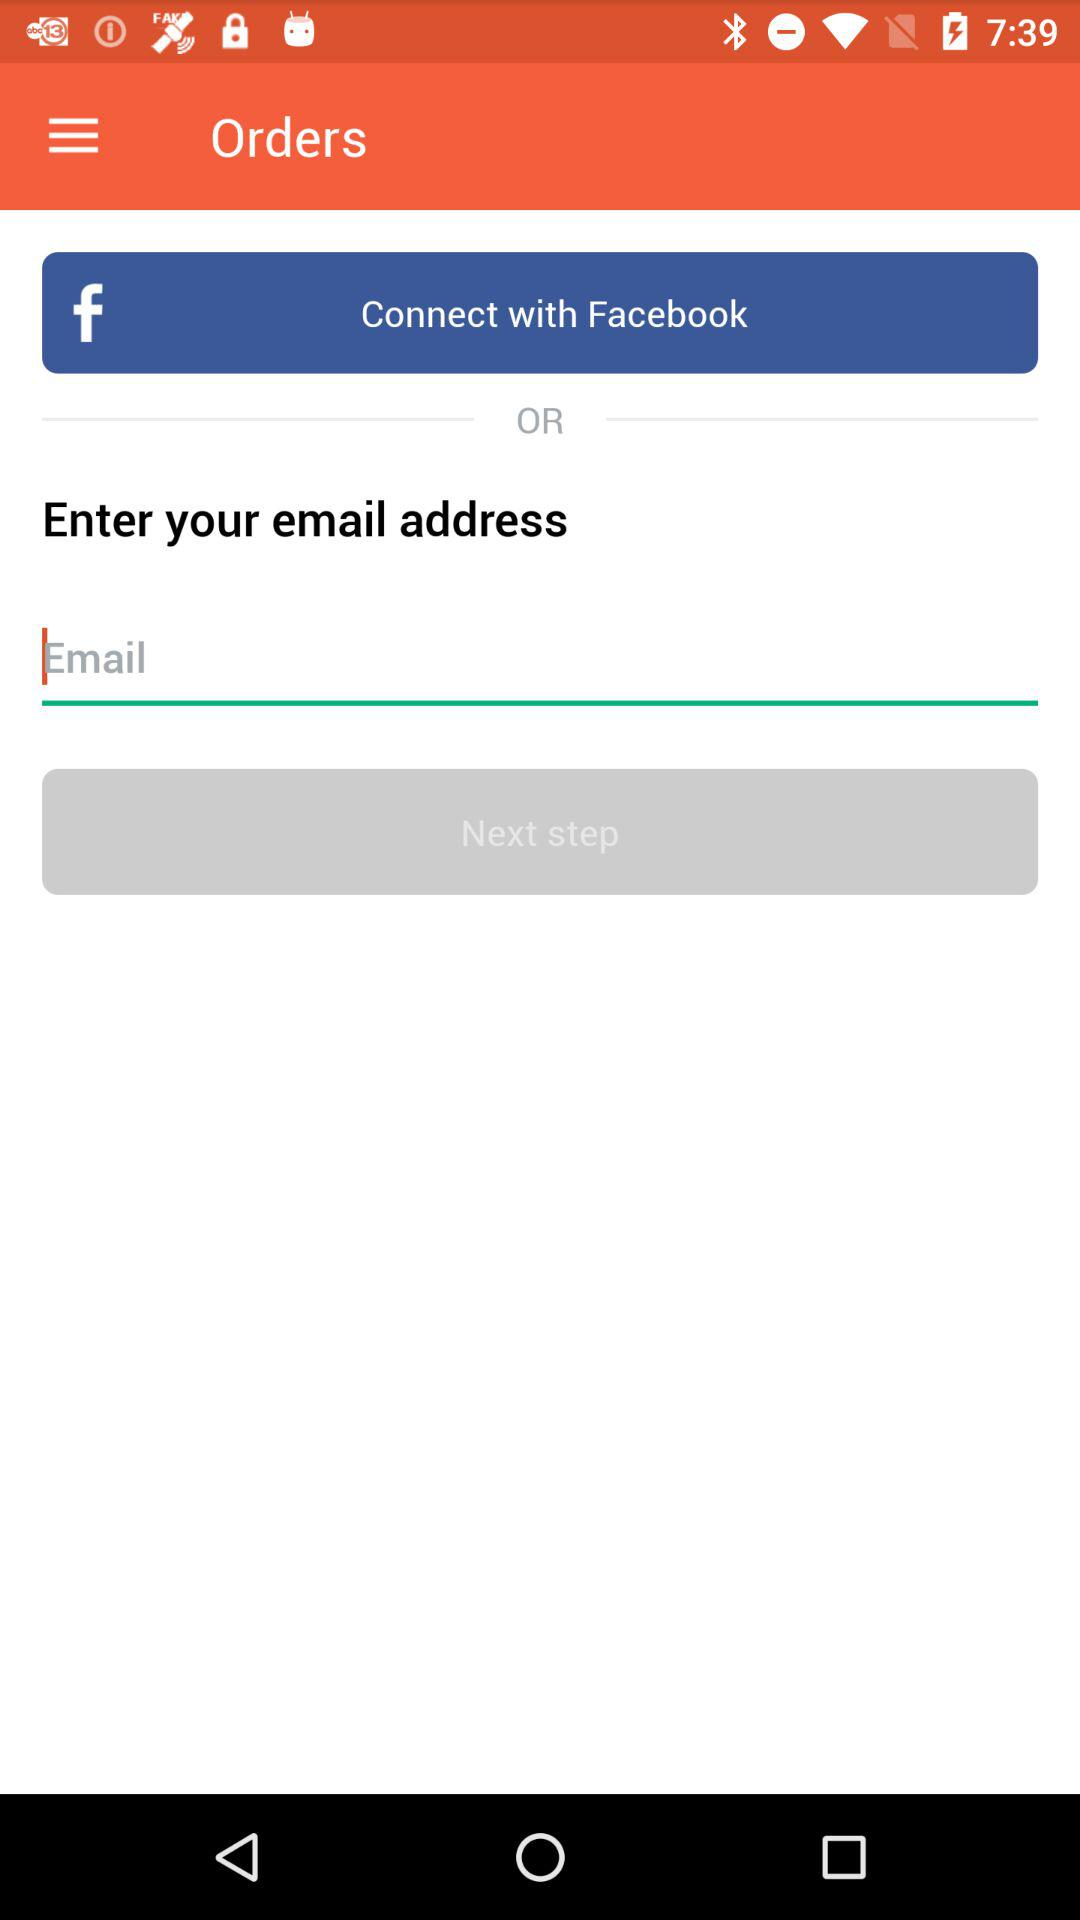How many options are there to log in to my account?
Answer the question using a single word or phrase. 2 